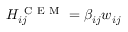Convert formula to latex. <formula><loc_0><loc_0><loc_500><loc_500>H _ { i j } ^ { C E M } = \beta _ { i j } w _ { i j }</formula> 